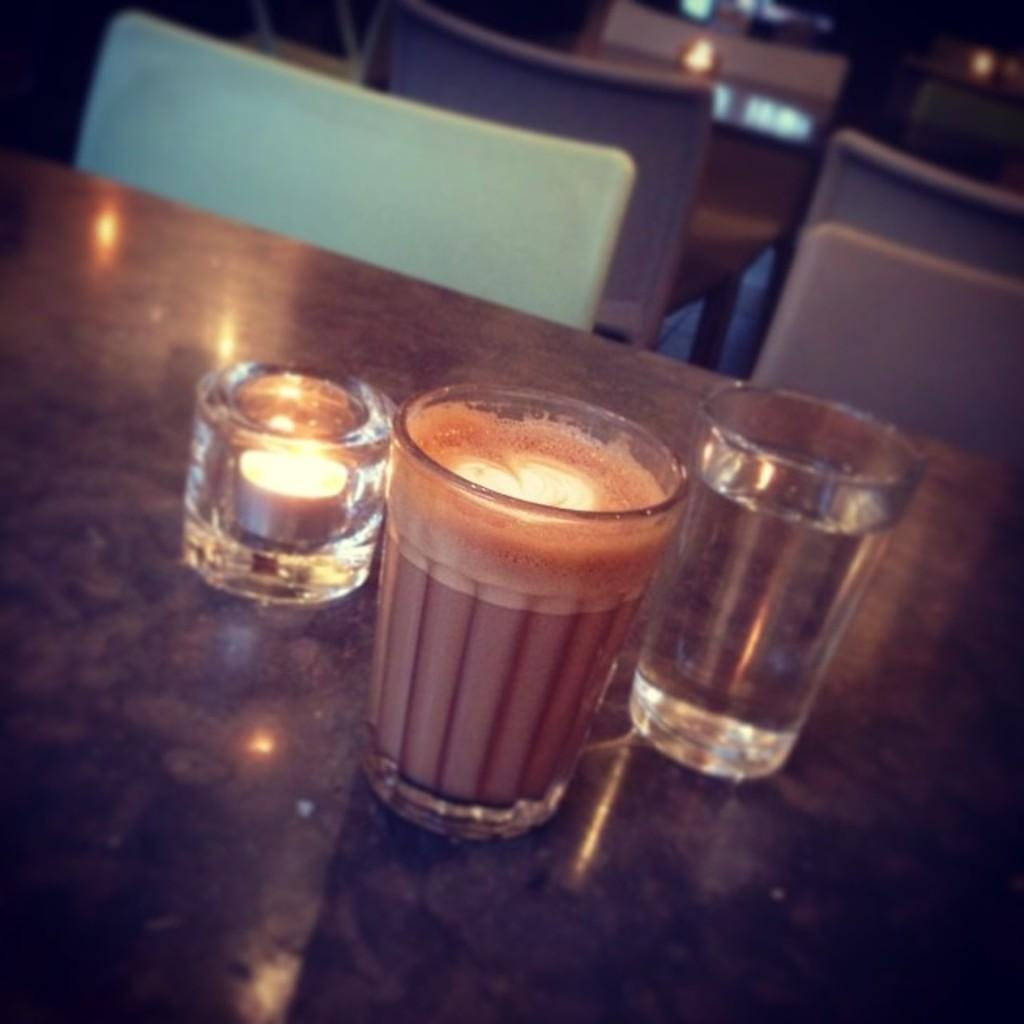What type of furniture is present in the image? There are tables and chairs in the image. What objects are placed on the tables? There are glasses on the table in the image. What type of soup is being served in the image? There is no soup present in the image; it only shows tables, chairs, and glasses on the table. 